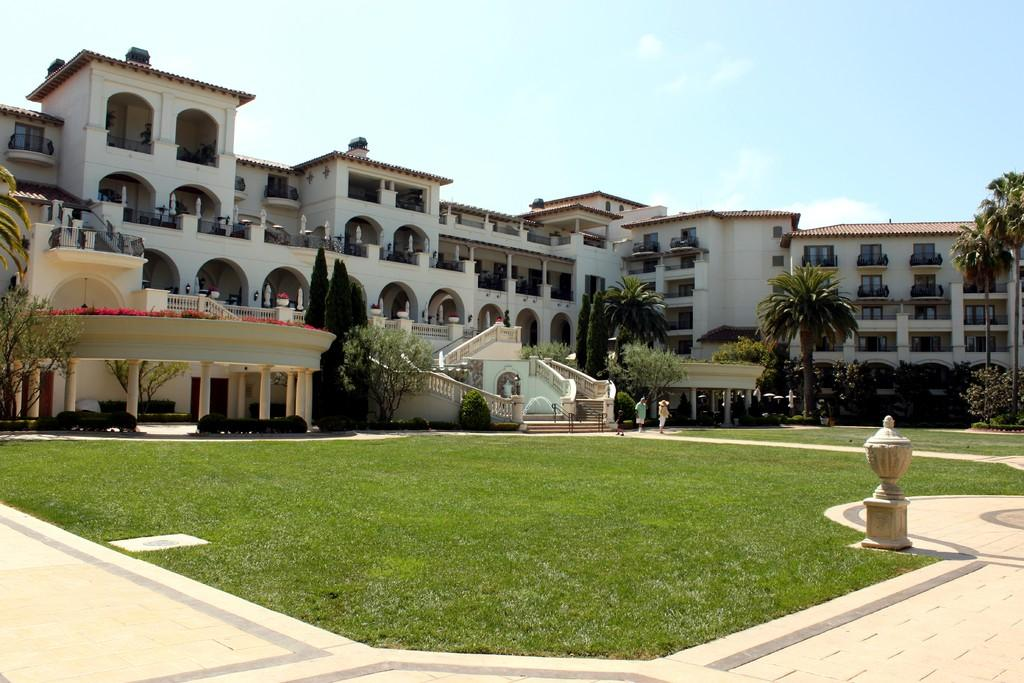What is the main object in the image? There is an object in the image, but the specific object is not mentioned in the facts. How many people are in the image? There are two people in the image. Where are the people located? The people are on a path. What type of vegetation is present in the image? Grass is present in the image. What architectural features can be seen in the image? There are pillars in the image. What type of structures are visible in the image? There are buildings with windows in the image. What can be seen in the background of the image? The sky is visible in the background of the image. What type of fold can be seen in the image? There is no fold present in the image. What kind of wire is used to support the object in the image? The facts do not mention any wire supporting the object in the image. 